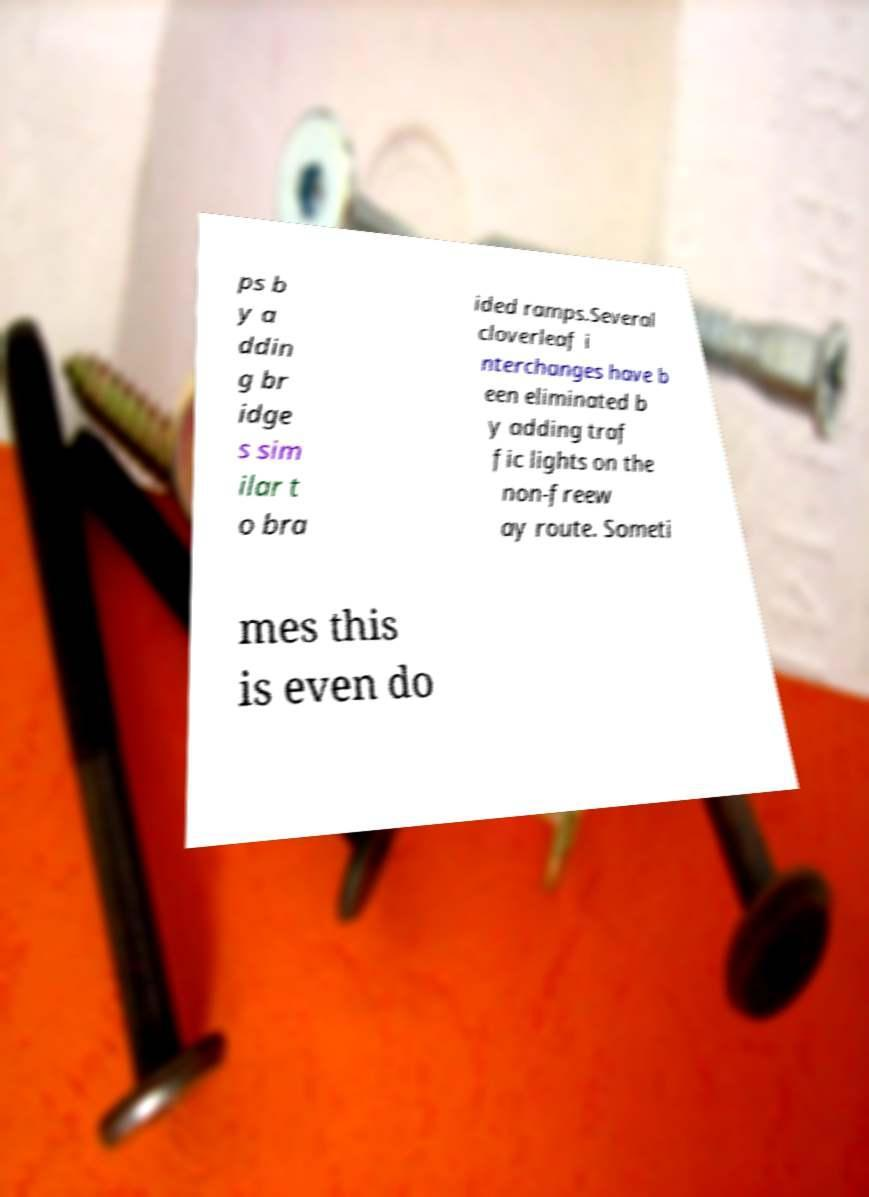What messages or text are displayed in this image? I need them in a readable, typed format. ps b y a ddin g br idge s sim ilar t o bra ided ramps.Several cloverleaf i nterchanges have b een eliminated b y adding traf fic lights on the non-freew ay route. Someti mes this is even do 